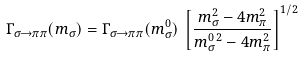<formula> <loc_0><loc_0><loc_500><loc_500>\Gamma _ { \sigma \rightarrow \pi \pi } ( m _ { \sigma } ) = \Gamma _ { \sigma \rightarrow \pi \pi } ( m _ { \sigma } ^ { 0 } ) \, \left [ \frac { m _ { \sigma } ^ { 2 } - 4 m _ { \pi } ^ { 2 } } { m _ { \sigma } ^ { 0 \, 2 } - 4 m _ { \pi } ^ { 2 } } \right ] ^ { 1 / 2 }</formula> 